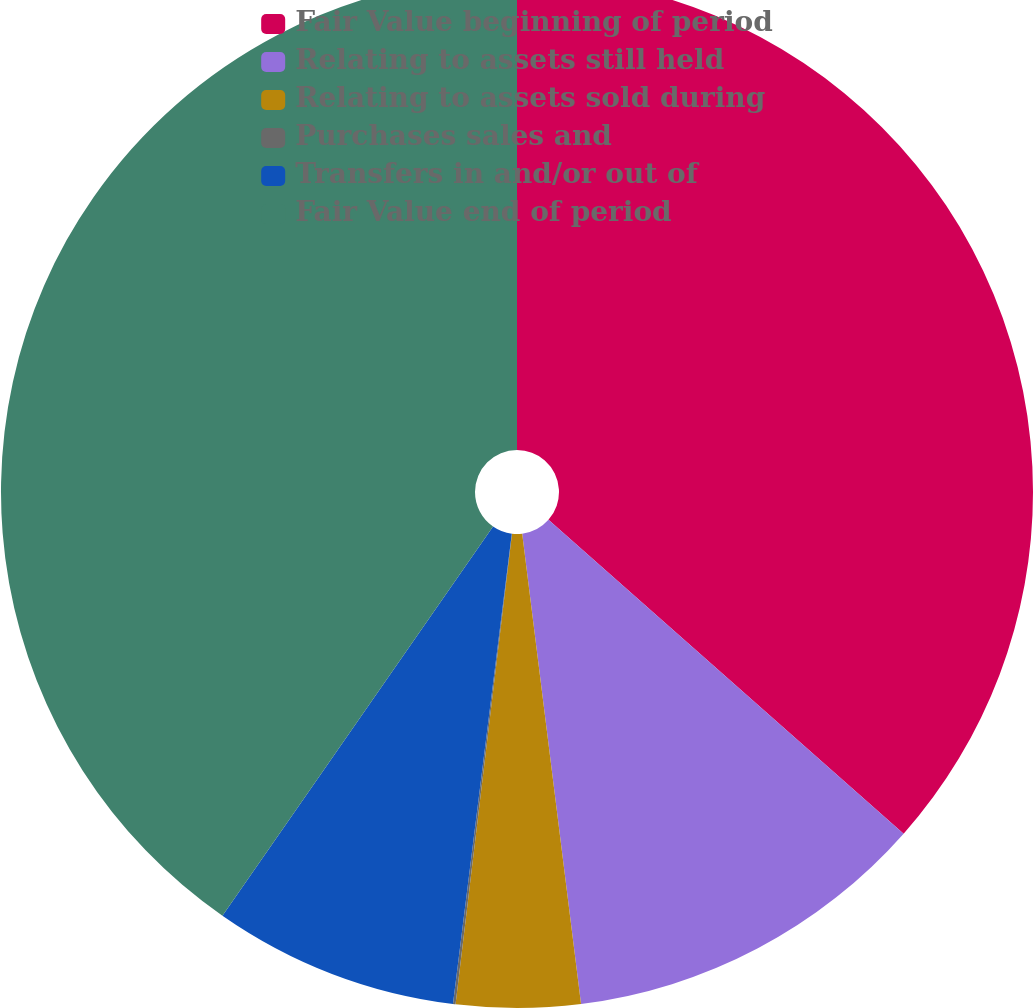Convert chart. <chart><loc_0><loc_0><loc_500><loc_500><pie_chart><fcel>Fair Value beginning of period<fcel>Relating to assets still held<fcel>Relating to assets sold during<fcel>Purchases sales and<fcel>Transfers in and/or out of<fcel>Fair Value end of period<nl><fcel>36.52%<fcel>11.5%<fcel>3.88%<fcel>0.08%<fcel>7.69%<fcel>40.33%<nl></chart> 